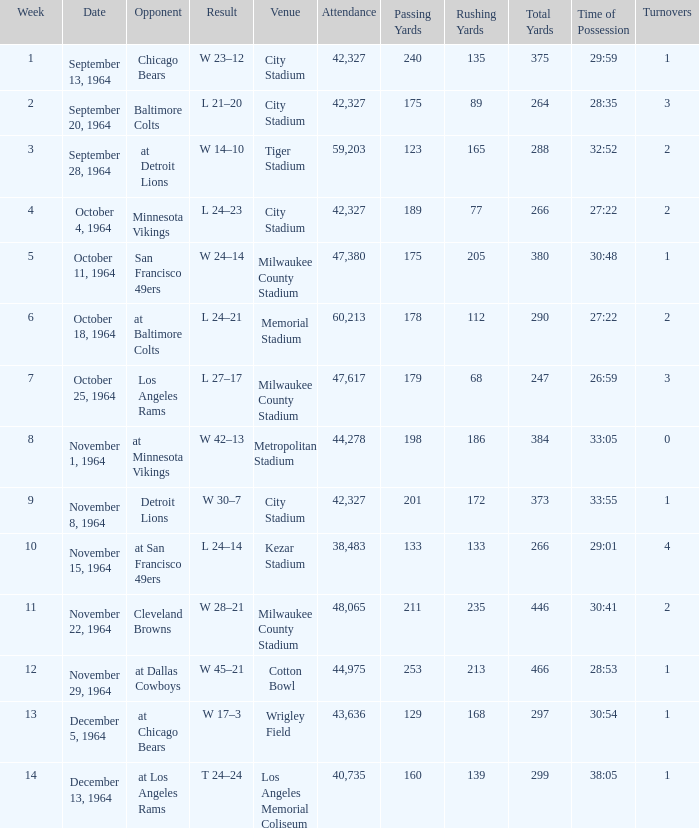What venue held that game with a result of l 24–14? Kezar Stadium. Can you give me this table as a dict? {'header': ['Week', 'Date', 'Opponent', 'Result', 'Venue', 'Attendance', 'Passing Yards', 'Rushing Yards', 'Total Yards', 'Time of Possession', 'Turnovers'], 'rows': [['1', 'September 13, 1964', 'Chicago Bears', 'W 23–12', 'City Stadium', '42,327', '240', '135', '375', '29:59', '1'], ['2', 'September 20, 1964', 'Baltimore Colts', 'L 21–20', 'City Stadium', '42,327', '175', '89', '264', '28:35', '3'], ['3', 'September 28, 1964', 'at Detroit Lions', 'W 14–10', 'Tiger Stadium', '59,203', '123', '165', '288', '32:52', '2'], ['4', 'October 4, 1964', 'Minnesota Vikings', 'L 24–23', 'City Stadium', '42,327', '189', '77', '266', '27:22', '2'], ['5', 'October 11, 1964', 'San Francisco 49ers', 'W 24–14', 'Milwaukee County Stadium', '47,380', '175', '205', '380', '30:48', '1'], ['6', 'October 18, 1964', 'at Baltimore Colts', 'L 24–21', 'Memorial Stadium', '60,213', '178', '112', '290', '27:22', '2'], ['7', 'October 25, 1964', 'Los Angeles Rams', 'L 27–17', 'Milwaukee County Stadium', '47,617', '179', '68', '247', '26:59', '3'], ['8', 'November 1, 1964', 'at Minnesota Vikings', 'W 42–13', 'Metropolitan Stadium', '44,278', '198', '186', '384', '33:05', '0'], ['9', 'November 8, 1964', 'Detroit Lions', 'W 30–7', 'City Stadium', '42,327', '201', '172', '373', '33:55', '1'], ['10', 'November 15, 1964', 'at San Francisco 49ers', 'L 24–14', 'Kezar Stadium', '38,483', '133', '133', '266', '29:01', '4'], ['11', 'November 22, 1964', 'Cleveland Browns', 'W 28–21', 'Milwaukee County Stadium', '48,065', '211', '235', '446', '30:41', '2'], ['12', 'November 29, 1964', 'at Dallas Cowboys', 'W 45–21', 'Cotton Bowl', '44,975', '253', '213', '466', '28:53', '1'], ['13', 'December 5, 1964', 'at Chicago Bears', 'W 17–3', 'Wrigley Field', '43,636', '129', '168', '297', '30:54', '1'], ['14', 'December 13, 1964', 'at Los Angeles Rams', 'T 24–24', 'Los Angeles Memorial Coliseum', '40,735', '160', '139', '299', '38:05', '1']]} 